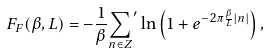Convert formula to latex. <formula><loc_0><loc_0><loc_500><loc_500>F _ { F } ( \beta , L ) = - \frac { 1 } { \beta } { \sum _ { n \in { Z } } } ^ { \prime } \ln { \left ( 1 + e ^ { - 2 \pi \frac { \beta } { L } | n | } \right ) } \, ,</formula> 